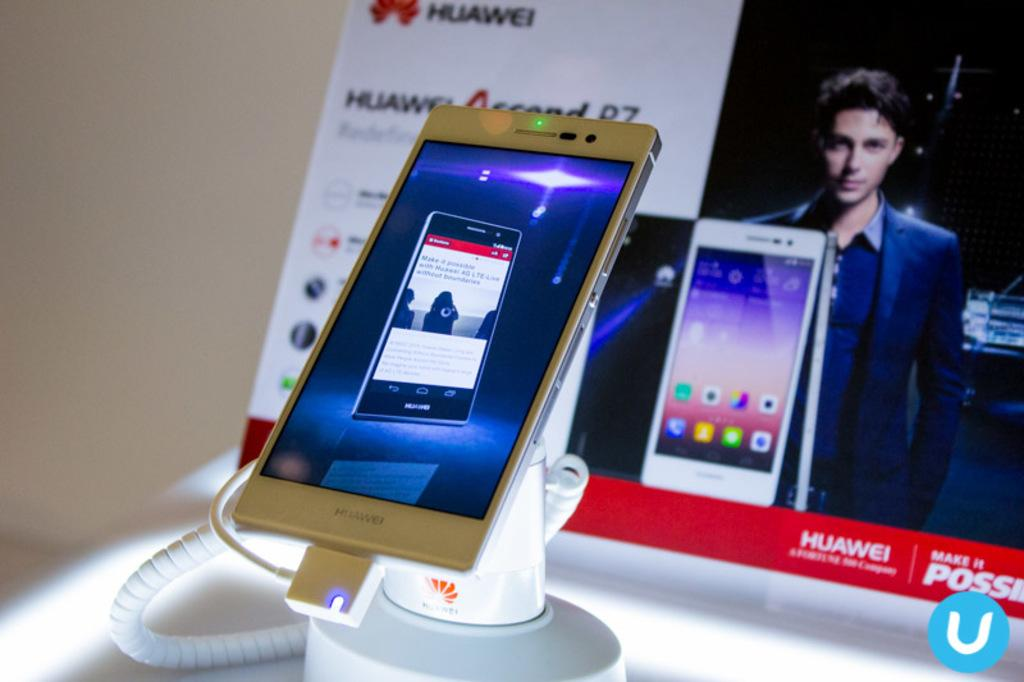Provide a one-sentence caption for the provided image. A phone from the company Huawei in front of an ad. 